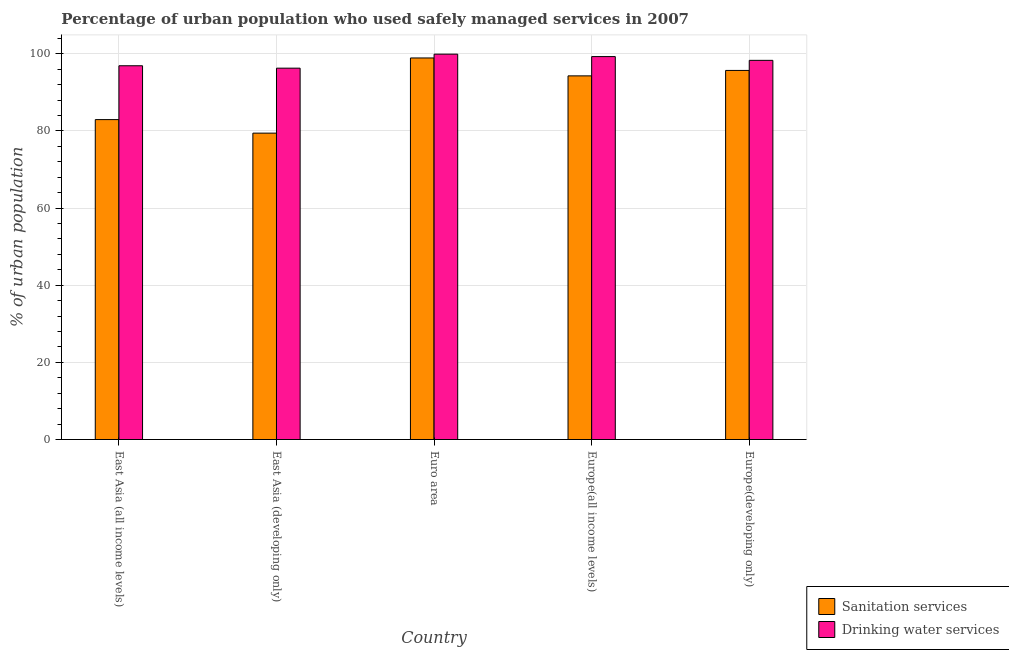How many different coloured bars are there?
Give a very brief answer. 2. How many groups of bars are there?
Your answer should be very brief. 5. How many bars are there on the 4th tick from the right?
Your answer should be very brief. 2. What is the label of the 5th group of bars from the left?
Ensure brevity in your answer.  Europe(developing only). What is the percentage of urban population who used sanitation services in Europe(all income levels)?
Your answer should be very brief. 94.29. Across all countries, what is the maximum percentage of urban population who used drinking water services?
Make the answer very short. 99.93. Across all countries, what is the minimum percentage of urban population who used sanitation services?
Your response must be concise. 79.45. In which country was the percentage of urban population who used drinking water services minimum?
Offer a very short reply. East Asia (developing only). What is the total percentage of urban population who used drinking water services in the graph?
Make the answer very short. 490.75. What is the difference between the percentage of urban population who used drinking water services in Europe(all income levels) and that in Europe(developing only)?
Your answer should be compact. 0.98. What is the difference between the percentage of urban population who used sanitation services in East Asia (all income levels) and the percentage of urban population who used drinking water services in Europe(developing only)?
Your answer should be compact. -15.36. What is the average percentage of urban population who used sanitation services per country?
Offer a terse response. 90.27. What is the difference between the percentage of urban population who used sanitation services and percentage of urban population who used drinking water services in Europe(developing only)?
Give a very brief answer. -2.61. In how many countries, is the percentage of urban population who used sanitation services greater than 76 %?
Your answer should be very brief. 5. What is the ratio of the percentage of urban population who used drinking water services in East Asia (all income levels) to that in Europe(all income levels)?
Your answer should be compact. 0.98. Is the percentage of urban population who used sanitation services in East Asia (all income levels) less than that in Euro area?
Provide a succinct answer. Yes. Is the difference between the percentage of urban population who used sanitation services in Euro area and Europe(developing only) greater than the difference between the percentage of urban population who used drinking water services in Euro area and Europe(developing only)?
Offer a very short reply. Yes. What is the difference between the highest and the second highest percentage of urban population who used sanitation services?
Offer a very short reply. 3.23. What is the difference between the highest and the lowest percentage of urban population who used drinking water services?
Your response must be concise. 3.63. In how many countries, is the percentage of urban population who used drinking water services greater than the average percentage of urban population who used drinking water services taken over all countries?
Your answer should be very brief. 3. What does the 1st bar from the left in Europe(developing only) represents?
Your answer should be compact. Sanitation services. What does the 2nd bar from the right in Europe(developing only) represents?
Your answer should be compact. Sanitation services. Are all the bars in the graph horizontal?
Make the answer very short. No. Are the values on the major ticks of Y-axis written in scientific E-notation?
Give a very brief answer. No. Does the graph contain grids?
Keep it short and to the point. Yes. Where does the legend appear in the graph?
Keep it short and to the point. Bottom right. How many legend labels are there?
Provide a succinct answer. 2. What is the title of the graph?
Provide a succinct answer. Percentage of urban population who used safely managed services in 2007. Does "Female labor force" appear as one of the legend labels in the graph?
Offer a terse response. No. What is the label or title of the X-axis?
Your answer should be very brief. Country. What is the label or title of the Y-axis?
Your answer should be very brief. % of urban population. What is the % of urban population of Sanitation services in East Asia (all income levels)?
Provide a succinct answer. 82.95. What is the % of urban population of Drinking water services in East Asia (all income levels)?
Keep it short and to the point. 96.92. What is the % of urban population of Sanitation services in East Asia (developing only)?
Your response must be concise. 79.45. What is the % of urban population of Drinking water services in East Asia (developing only)?
Make the answer very short. 96.29. What is the % of urban population of Sanitation services in Euro area?
Give a very brief answer. 98.94. What is the % of urban population of Drinking water services in Euro area?
Your response must be concise. 99.93. What is the % of urban population in Sanitation services in Europe(all income levels)?
Provide a succinct answer. 94.29. What is the % of urban population of Drinking water services in Europe(all income levels)?
Your response must be concise. 99.29. What is the % of urban population of Sanitation services in Europe(developing only)?
Your answer should be compact. 95.7. What is the % of urban population of Drinking water services in Europe(developing only)?
Offer a very short reply. 98.32. Across all countries, what is the maximum % of urban population of Sanitation services?
Offer a very short reply. 98.94. Across all countries, what is the maximum % of urban population in Drinking water services?
Ensure brevity in your answer.  99.93. Across all countries, what is the minimum % of urban population of Sanitation services?
Your answer should be compact. 79.45. Across all countries, what is the minimum % of urban population in Drinking water services?
Your response must be concise. 96.29. What is the total % of urban population of Sanitation services in the graph?
Your answer should be compact. 451.33. What is the total % of urban population of Drinking water services in the graph?
Your answer should be very brief. 490.75. What is the difference between the % of urban population of Sanitation services in East Asia (all income levels) and that in East Asia (developing only)?
Offer a very short reply. 3.51. What is the difference between the % of urban population of Drinking water services in East Asia (all income levels) and that in East Asia (developing only)?
Provide a succinct answer. 0.62. What is the difference between the % of urban population of Sanitation services in East Asia (all income levels) and that in Euro area?
Keep it short and to the point. -15.99. What is the difference between the % of urban population in Drinking water services in East Asia (all income levels) and that in Euro area?
Your answer should be very brief. -3.01. What is the difference between the % of urban population in Sanitation services in East Asia (all income levels) and that in Europe(all income levels)?
Keep it short and to the point. -11.34. What is the difference between the % of urban population of Drinking water services in East Asia (all income levels) and that in Europe(all income levels)?
Your answer should be very brief. -2.38. What is the difference between the % of urban population in Sanitation services in East Asia (all income levels) and that in Europe(developing only)?
Ensure brevity in your answer.  -12.75. What is the difference between the % of urban population in Drinking water services in East Asia (all income levels) and that in Europe(developing only)?
Offer a terse response. -1.4. What is the difference between the % of urban population of Sanitation services in East Asia (developing only) and that in Euro area?
Your answer should be very brief. -19.49. What is the difference between the % of urban population in Drinking water services in East Asia (developing only) and that in Euro area?
Provide a succinct answer. -3.63. What is the difference between the % of urban population in Sanitation services in East Asia (developing only) and that in Europe(all income levels)?
Provide a short and direct response. -14.85. What is the difference between the % of urban population of Drinking water services in East Asia (developing only) and that in Europe(all income levels)?
Provide a short and direct response. -3. What is the difference between the % of urban population of Sanitation services in East Asia (developing only) and that in Europe(developing only)?
Ensure brevity in your answer.  -16.26. What is the difference between the % of urban population in Drinking water services in East Asia (developing only) and that in Europe(developing only)?
Provide a short and direct response. -2.02. What is the difference between the % of urban population of Sanitation services in Euro area and that in Europe(all income levels)?
Make the answer very short. 4.64. What is the difference between the % of urban population of Drinking water services in Euro area and that in Europe(all income levels)?
Offer a terse response. 0.63. What is the difference between the % of urban population in Sanitation services in Euro area and that in Europe(developing only)?
Give a very brief answer. 3.23. What is the difference between the % of urban population in Drinking water services in Euro area and that in Europe(developing only)?
Your answer should be very brief. 1.61. What is the difference between the % of urban population of Sanitation services in Europe(all income levels) and that in Europe(developing only)?
Keep it short and to the point. -1.41. What is the difference between the % of urban population in Drinking water services in Europe(all income levels) and that in Europe(developing only)?
Give a very brief answer. 0.98. What is the difference between the % of urban population in Sanitation services in East Asia (all income levels) and the % of urban population in Drinking water services in East Asia (developing only)?
Ensure brevity in your answer.  -13.34. What is the difference between the % of urban population of Sanitation services in East Asia (all income levels) and the % of urban population of Drinking water services in Euro area?
Your answer should be very brief. -16.97. What is the difference between the % of urban population in Sanitation services in East Asia (all income levels) and the % of urban population in Drinking water services in Europe(all income levels)?
Ensure brevity in your answer.  -16.34. What is the difference between the % of urban population in Sanitation services in East Asia (all income levels) and the % of urban population in Drinking water services in Europe(developing only)?
Your answer should be very brief. -15.36. What is the difference between the % of urban population in Sanitation services in East Asia (developing only) and the % of urban population in Drinking water services in Euro area?
Provide a short and direct response. -20.48. What is the difference between the % of urban population in Sanitation services in East Asia (developing only) and the % of urban population in Drinking water services in Europe(all income levels)?
Ensure brevity in your answer.  -19.85. What is the difference between the % of urban population of Sanitation services in East Asia (developing only) and the % of urban population of Drinking water services in Europe(developing only)?
Offer a very short reply. -18.87. What is the difference between the % of urban population of Sanitation services in Euro area and the % of urban population of Drinking water services in Europe(all income levels)?
Give a very brief answer. -0.35. What is the difference between the % of urban population in Sanitation services in Euro area and the % of urban population in Drinking water services in Europe(developing only)?
Your answer should be very brief. 0.62. What is the difference between the % of urban population of Sanitation services in Europe(all income levels) and the % of urban population of Drinking water services in Europe(developing only)?
Your answer should be very brief. -4.02. What is the average % of urban population of Sanitation services per country?
Ensure brevity in your answer.  90.27. What is the average % of urban population in Drinking water services per country?
Your response must be concise. 98.15. What is the difference between the % of urban population in Sanitation services and % of urban population in Drinking water services in East Asia (all income levels)?
Give a very brief answer. -13.96. What is the difference between the % of urban population in Sanitation services and % of urban population in Drinking water services in East Asia (developing only)?
Keep it short and to the point. -16.85. What is the difference between the % of urban population in Sanitation services and % of urban population in Drinking water services in Euro area?
Your answer should be very brief. -0.99. What is the difference between the % of urban population of Sanitation services and % of urban population of Drinking water services in Europe(all income levels)?
Make the answer very short. -5. What is the difference between the % of urban population in Sanitation services and % of urban population in Drinking water services in Europe(developing only)?
Keep it short and to the point. -2.61. What is the ratio of the % of urban population of Sanitation services in East Asia (all income levels) to that in East Asia (developing only)?
Offer a terse response. 1.04. What is the ratio of the % of urban population in Drinking water services in East Asia (all income levels) to that in East Asia (developing only)?
Your response must be concise. 1.01. What is the ratio of the % of urban population of Sanitation services in East Asia (all income levels) to that in Euro area?
Provide a short and direct response. 0.84. What is the ratio of the % of urban population in Drinking water services in East Asia (all income levels) to that in Euro area?
Offer a terse response. 0.97. What is the ratio of the % of urban population in Sanitation services in East Asia (all income levels) to that in Europe(all income levels)?
Provide a short and direct response. 0.88. What is the ratio of the % of urban population of Drinking water services in East Asia (all income levels) to that in Europe(all income levels)?
Your response must be concise. 0.98. What is the ratio of the % of urban population of Sanitation services in East Asia (all income levels) to that in Europe(developing only)?
Ensure brevity in your answer.  0.87. What is the ratio of the % of urban population of Drinking water services in East Asia (all income levels) to that in Europe(developing only)?
Provide a short and direct response. 0.99. What is the ratio of the % of urban population in Sanitation services in East Asia (developing only) to that in Euro area?
Ensure brevity in your answer.  0.8. What is the ratio of the % of urban population of Drinking water services in East Asia (developing only) to that in Euro area?
Keep it short and to the point. 0.96. What is the ratio of the % of urban population in Sanitation services in East Asia (developing only) to that in Europe(all income levels)?
Offer a terse response. 0.84. What is the ratio of the % of urban population in Drinking water services in East Asia (developing only) to that in Europe(all income levels)?
Make the answer very short. 0.97. What is the ratio of the % of urban population of Sanitation services in East Asia (developing only) to that in Europe(developing only)?
Your answer should be very brief. 0.83. What is the ratio of the % of urban population of Drinking water services in East Asia (developing only) to that in Europe(developing only)?
Offer a very short reply. 0.98. What is the ratio of the % of urban population of Sanitation services in Euro area to that in Europe(all income levels)?
Give a very brief answer. 1.05. What is the ratio of the % of urban population in Drinking water services in Euro area to that in Europe(all income levels)?
Provide a succinct answer. 1.01. What is the ratio of the % of urban population in Sanitation services in Euro area to that in Europe(developing only)?
Give a very brief answer. 1.03. What is the ratio of the % of urban population of Drinking water services in Euro area to that in Europe(developing only)?
Provide a short and direct response. 1.02. What is the ratio of the % of urban population in Sanitation services in Europe(all income levels) to that in Europe(developing only)?
Provide a succinct answer. 0.99. What is the ratio of the % of urban population in Drinking water services in Europe(all income levels) to that in Europe(developing only)?
Offer a terse response. 1.01. What is the difference between the highest and the second highest % of urban population of Sanitation services?
Provide a succinct answer. 3.23. What is the difference between the highest and the second highest % of urban population in Drinking water services?
Offer a terse response. 0.63. What is the difference between the highest and the lowest % of urban population in Sanitation services?
Your answer should be very brief. 19.49. What is the difference between the highest and the lowest % of urban population in Drinking water services?
Your response must be concise. 3.63. 